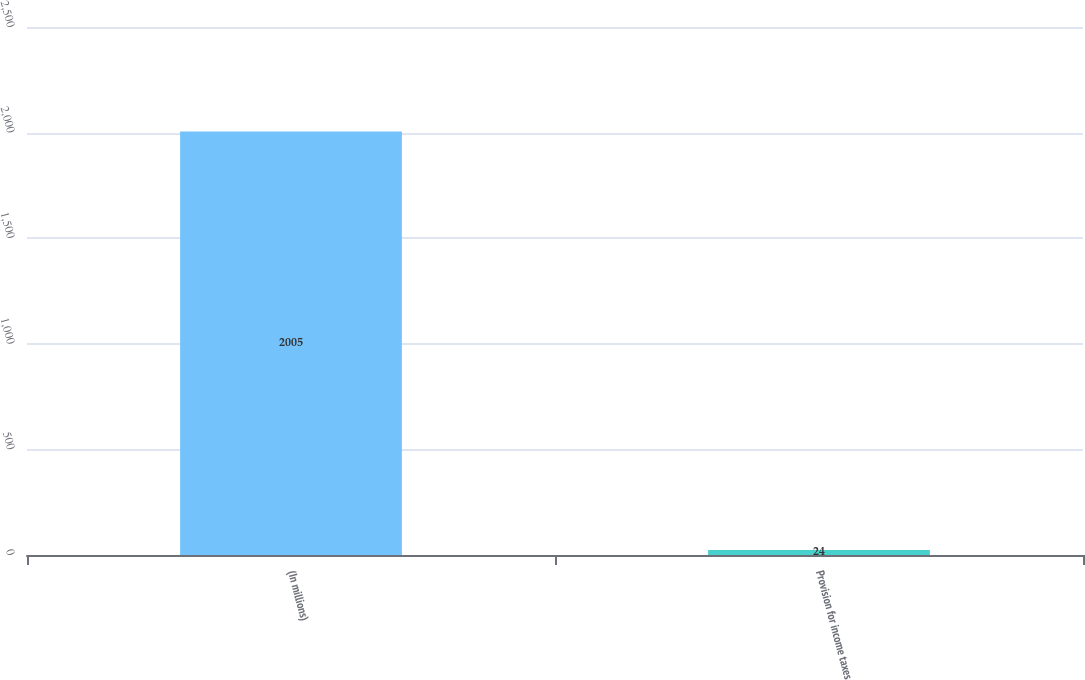Convert chart to OTSL. <chart><loc_0><loc_0><loc_500><loc_500><bar_chart><fcel>(In millions)<fcel>Provision for income taxes<nl><fcel>2005<fcel>24<nl></chart> 